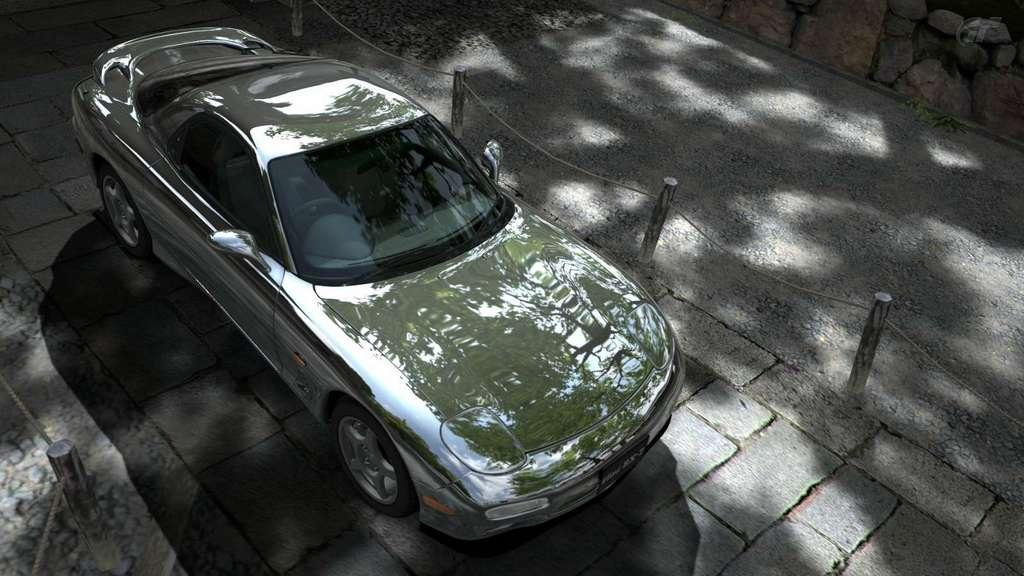What is the main subject in the center of the image? There is a car in the center of the image. What can be seen in the background of the image? There are barricades and a road visible in the background of the image. Are there any additional elements in the top right corner of the image? Yes, there are rocks in the top right corner of the image. What type of string is being used to control the car in the image? There is no string present in the image, and the car is not being controlled by any visible means. 